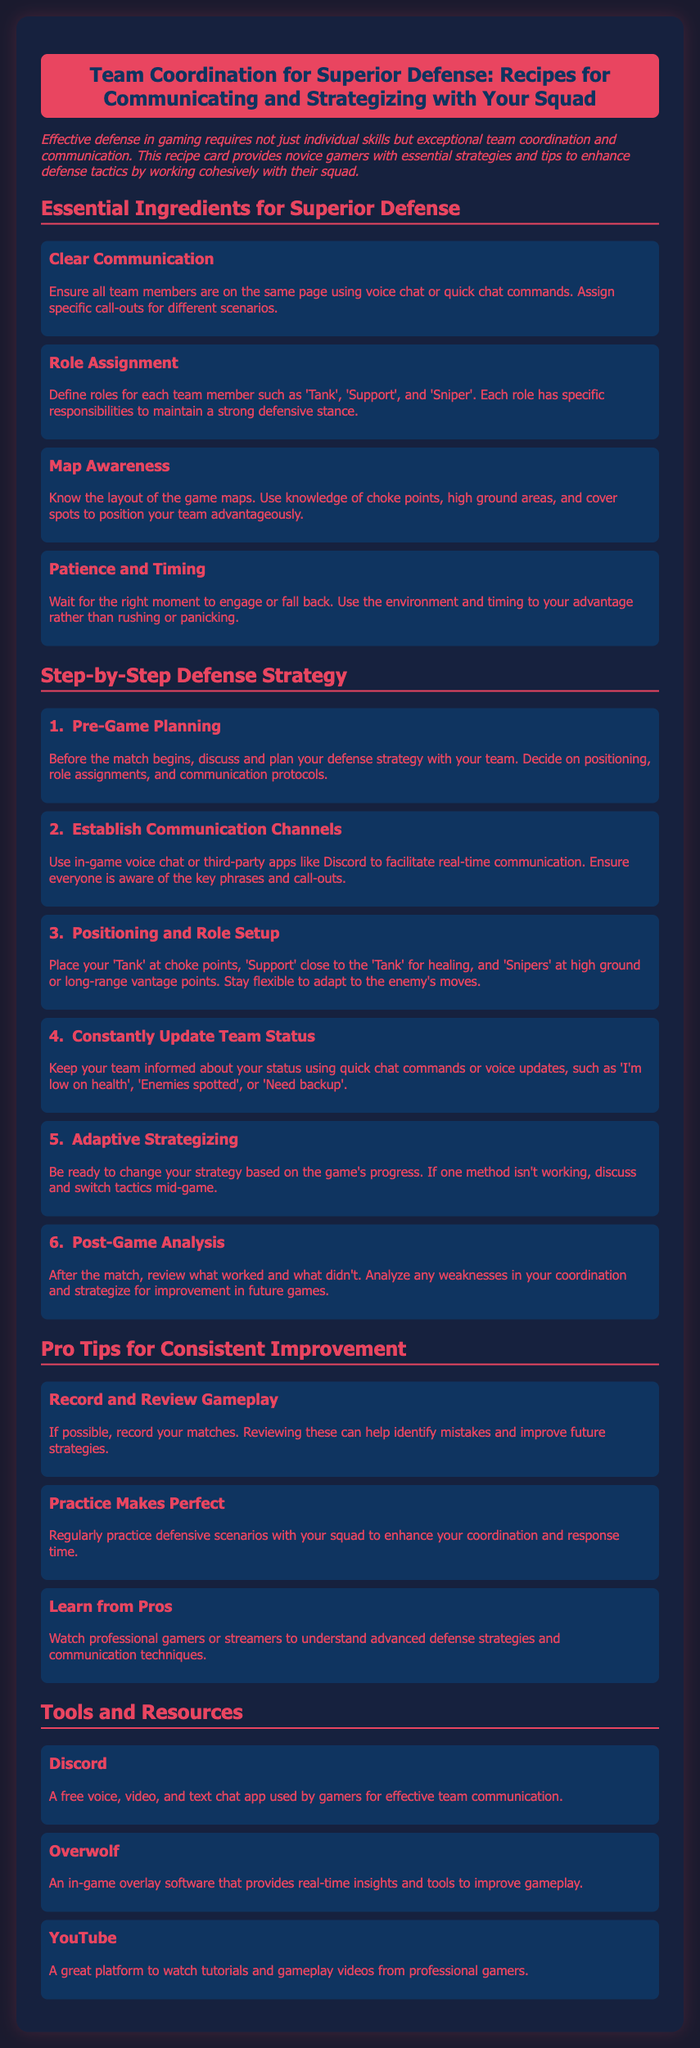What is the title of the document? The title of the document is located at the top of the rendered page, providing an overview of its content.
Answer: Team Coordination for Superior Defense: Recipes for Communicating and Strategizing with Your Squad How many essential ingredients are listed for superior defense? The number of essential ingredients can be determined by counting the entries under the "Essential Ingredients for Superior Defense" section.
Answer: Four What is the first step in the defense strategy? The first step is highlighted in the "Step-by-Step Defense Strategy" section and provides initial guidance on planning.
Answer: Pre-Game Planning What tool is recommended for effective team communication? The recommended tool for communication is specified in the "Tools and Resources" section.
Answer: Discord Which role is suggested to be placed at choke points? The specific role that should be positioned at choke points is mentioned in the "Positioning and Role Setup" step.
Answer: Tank What should you do after a match according to the document? The document suggests a specific action to take post-match, which is part of improving future performance.
Answer: Post-Game Analysis How can players improve their gameplay according to the Pro Tips? The Pro Tips section provides suggestions that focus on forms of practice to enhance defensive tactics.
Answer: Practice Makes Perfect What is one way to learn from advanced defense strategies? The document provides a suggestion for learning advanced techniques through observation of others.
Answer: Watch professional gamers or streamers 